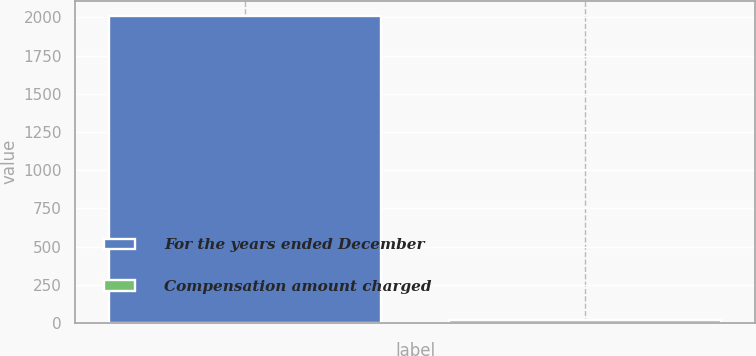Convert chart. <chart><loc_0><loc_0><loc_500><loc_500><bar_chart><fcel>For the years ended December<fcel>Compensation amount charged<nl><fcel>2010<fcel>20.3<nl></chart> 